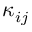<formula> <loc_0><loc_0><loc_500><loc_500>\kappa _ { i j }</formula> 